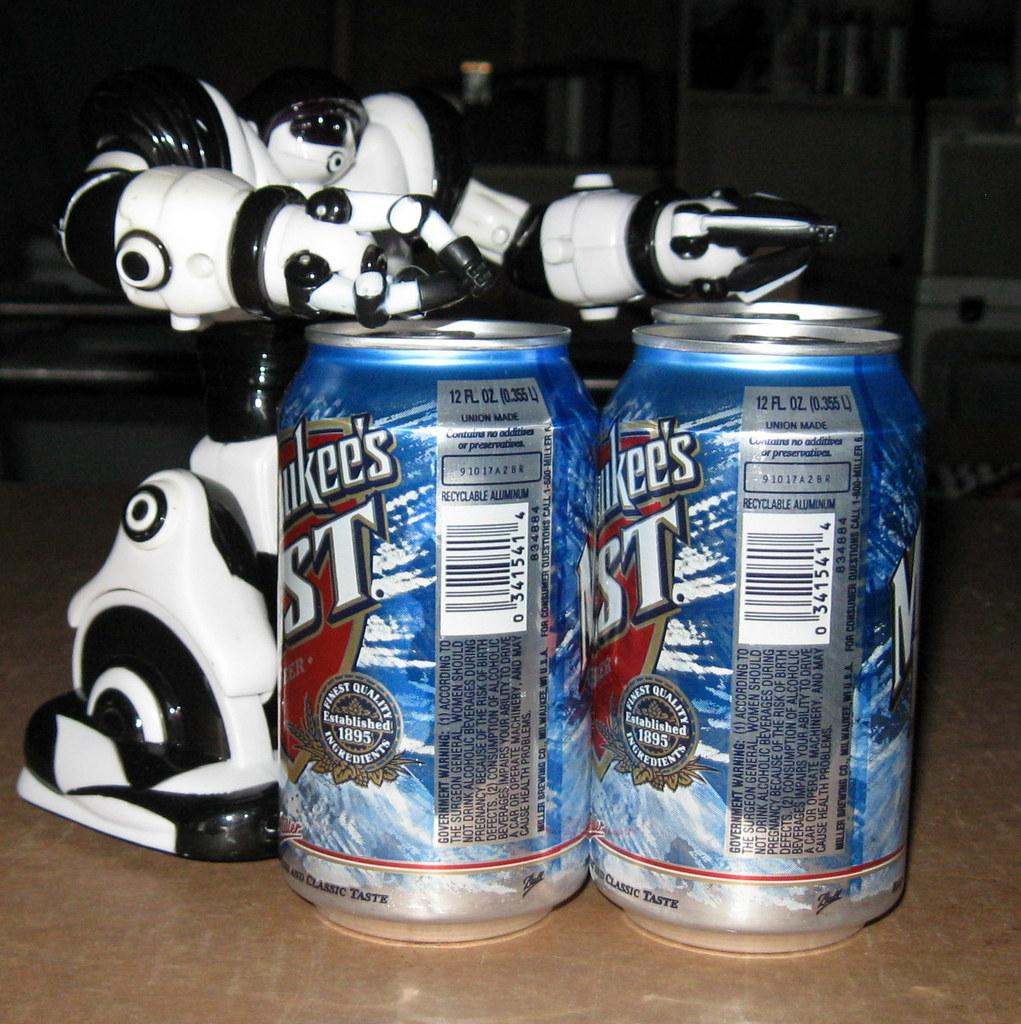<image>
Share a concise interpretation of the image provided. Two beer cans with one that says 0341541 in the back. 